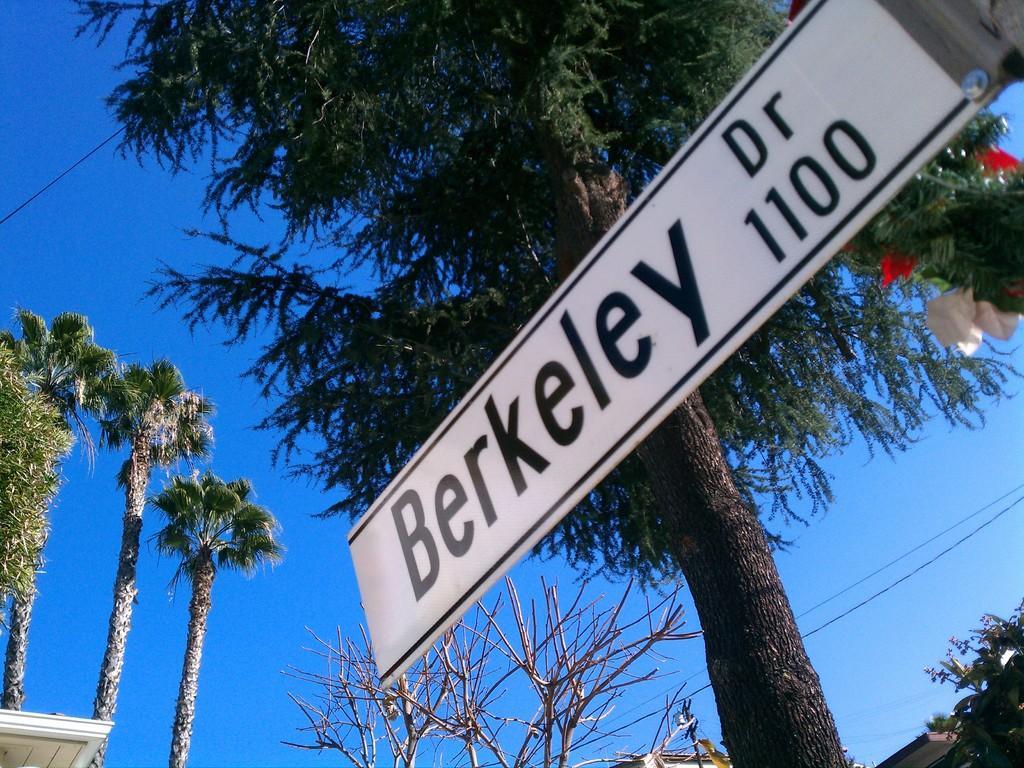How would you summarize this image in a sentence or two? There is a white color hoarding which is attached to the pole. In the background, there are trees and there is blue sky. 